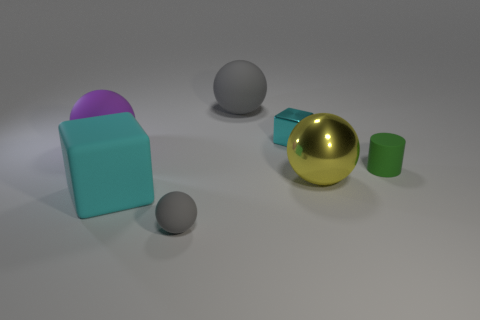Subtract 1 balls. How many balls are left? 3 Add 2 small green metallic objects. How many objects exist? 9 Subtract all blocks. How many objects are left? 5 Subtract 0 brown spheres. How many objects are left? 7 Subtract all gray objects. Subtract all yellow spheres. How many objects are left? 4 Add 3 large gray matte balls. How many large gray matte balls are left? 4 Add 7 large balls. How many large balls exist? 10 